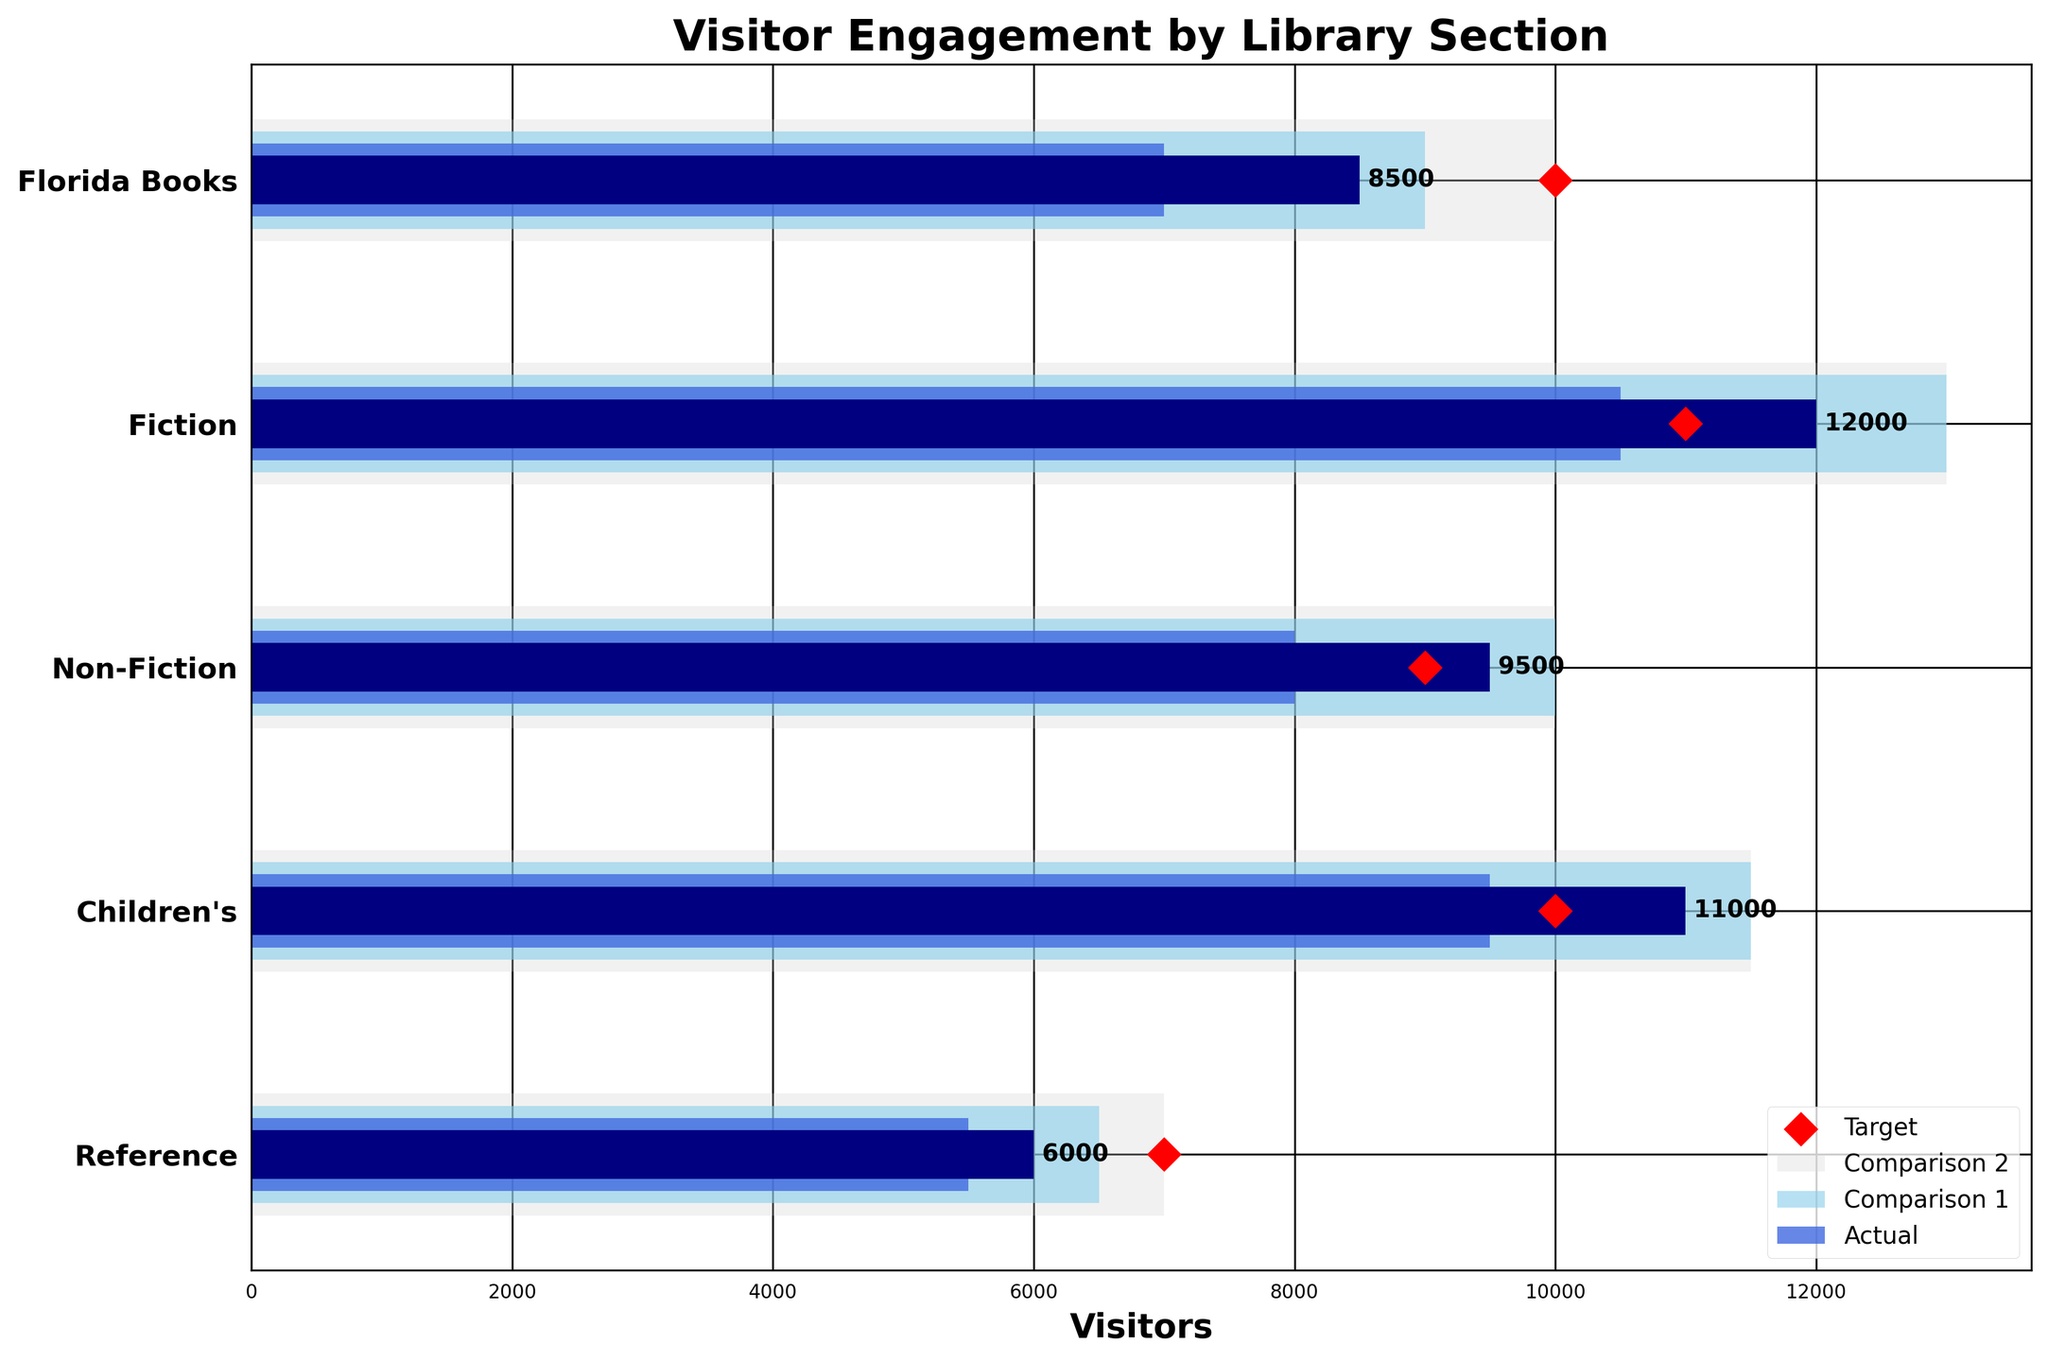What's the title of the chart? The title is displayed at the top of the chart. It gives an overview of what the chart is displaying.
Answer: Visitor Engagement by Library Section What is the color of the bars representing actual visitors? The bars representing actual visitors are shown in dark color.
Answer: Navy Which section had the highest number of actual visitors? By looking at the length of the navy bars (actual visitors), we can see which section has the longest bar.
Answer: Fiction Did the Florida Books section meet its target visitors? The target marker (red diamond) is at 10,000 while the actual visitors' bar is at 8,500, so it did not meet the target.
Answer: No How many sections have their actual visitors above their target visitors? By comparing the actual visitors' bars (navy) against their respective target markers (red diamonds), we can see how many sections have bars surpassing the markers.
Answer: 2 sections (Fiction and Non-Fiction) Which section has the most significant shortfall in meeting target visitors? Subtract the actual visitors' value from the target visitors' value for each section and find the maximum difference. The section with the highest positive difference did not meet the target the most. For Florida Books, it's 10,000 - 8,500 = 1,500.
Answer: Florida Books (1,500 shortfall) Is there any section where actual visitors are less than Comparison 1 visitors? Compare the length of the navy bars (actual visitors) with the royal blue bars (Comparison 1 visitors) for each section to see if any navy bar is shorter.
Answer: No Which section has the closest number of actual visitors to its Comparison 2 visitors? Find the difference between actual visitors and Comparison 2 visitors for each section and find the minimum difference.
Answer: Children's section (11,000 actual vs. 11,500 Comparison 2) How many visitors would Florida Books need to meet the Comparison 1 metric? Subtract the actual visitors' number from the Comparison 1 metric for the Florida Books section.
Answer: 7,000 - 8,500 = -1,500 (0 needed, it already exceeds) 